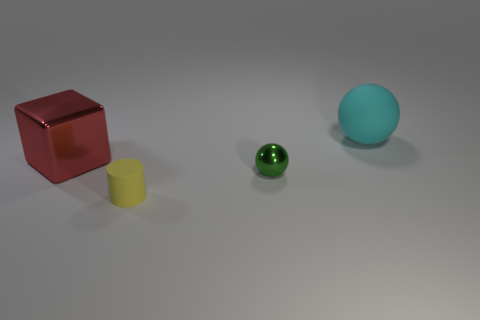Are there any small green objects to the right of the metallic thing that is on the right side of the yellow thing? Yes, there is a small green spherical object situated to the right of the silver cylindrical object, which in turn is positioned to the right of the yellow cylindrical object. 